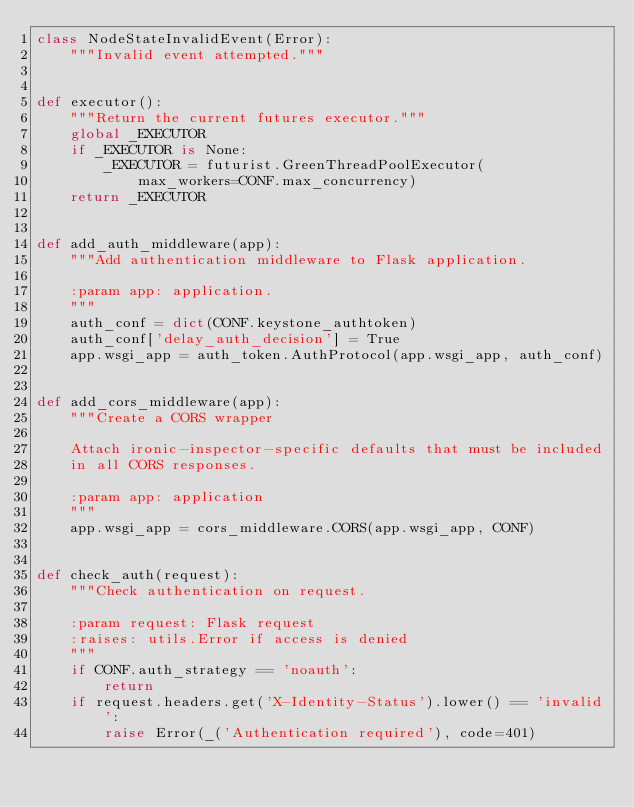<code> <loc_0><loc_0><loc_500><loc_500><_Python_>class NodeStateInvalidEvent(Error):
    """Invalid event attempted."""


def executor():
    """Return the current futures executor."""
    global _EXECUTOR
    if _EXECUTOR is None:
        _EXECUTOR = futurist.GreenThreadPoolExecutor(
            max_workers=CONF.max_concurrency)
    return _EXECUTOR


def add_auth_middleware(app):
    """Add authentication middleware to Flask application.

    :param app: application.
    """
    auth_conf = dict(CONF.keystone_authtoken)
    auth_conf['delay_auth_decision'] = True
    app.wsgi_app = auth_token.AuthProtocol(app.wsgi_app, auth_conf)


def add_cors_middleware(app):
    """Create a CORS wrapper

    Attach ironic-inspector-specific defaults that must be included
    in all CORS responses.

    :param app: application
    """
    app.wsgi_app = cors_middleware.CORS(app.wsgi_app, CONF)


def check_auth(request):
    """Check authentication on request.

    :param request: Flask request
    :raises: utils.Error if access is denied
    """
    if CONF.auth_strategy == 'noauth':
        return
    if request.headers.get('X-Identity-Status').lower() == 'invalid':
        raise Error(_('Authentication required'), code=401)</code> 